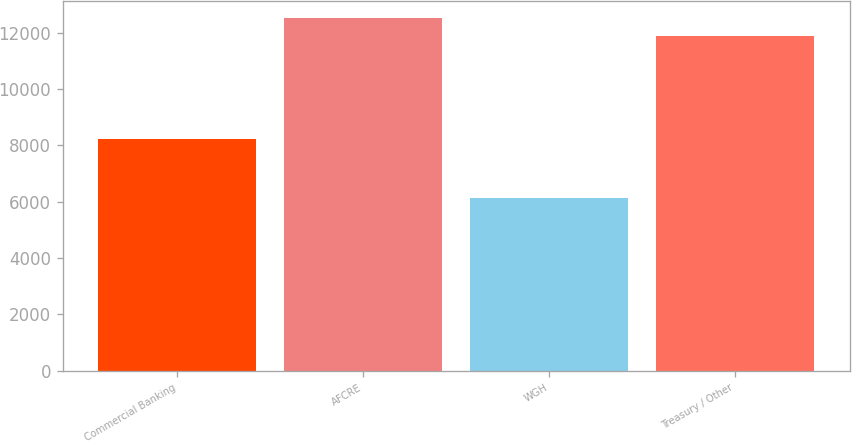Convert chart to OTSL. <chart><loc_0><loc_0><loc_500><loc_500><bar_chart><fcel>Commercial Banking<fcel>AFCRE<fcel>WGH<fcel>Treasury / Other<nl><fcel>8214<fcel>12506.6<fcel>6125<fcel>11883<nl></chart> 